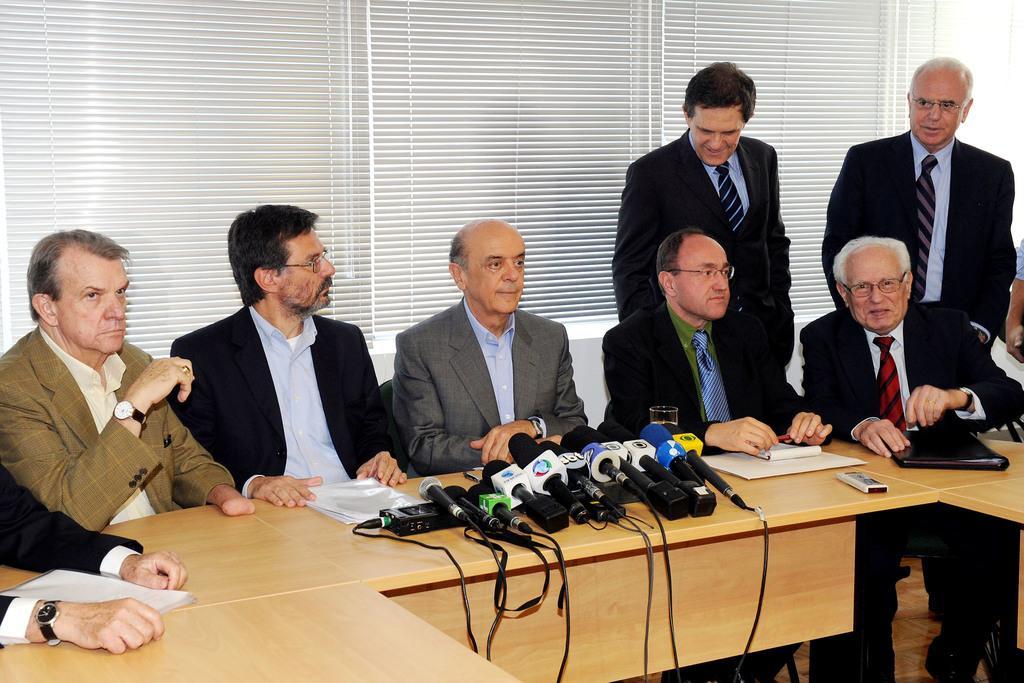Describe this image in one or two sentences. This image consists of many people sitting in the chairs. It looks like a conference hall. In the front, there is a table made up of wood on which there are many mics kept. In the background, there is a window along with window blind. 